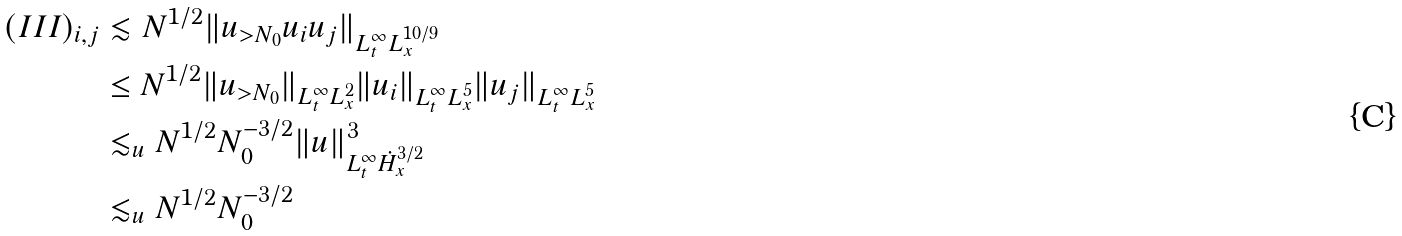Convert formula to latex. <formula><loc_0><loc_0><loc_500><loc_500>( I I I ) _ { i , j } & \lesssim N ^ { 1 / 2 } \| u _ { > N _ { 0 } } u _ { i } u _ { j } \| _ { L _ { t } ^ { \infty } L _ { x } ^ { 1 0 / 9 } } \\ & \leq N ^ { 1 / 2 } \| u _ { > N _ { 0 } } \| _ { L _ { t } ^ { \infty } L _ { x } ^ { 2 } } \| u _ { i } \| _ { L _ { t } ^ { \infty } L _ { x } ^ { 5 } } \| u _ { j } \| _ { L _ { t } ^ { \infty } L _ { x } ^ { 5 } } \\ & \lesssim _ { u } N ^ { 1 / 2 } N _ { 0 } ^ { - 3 / 2 } \| u \| _ { L _ { t } ^ { \infty } \dot { H } _ { x } ^ { 3 / 2 } } ^ { 3 } \\ & \lesssim _ { u } N ^ { 1 / 2 } N _ { 0 } ^ { - 3 / 2 }</formula> 